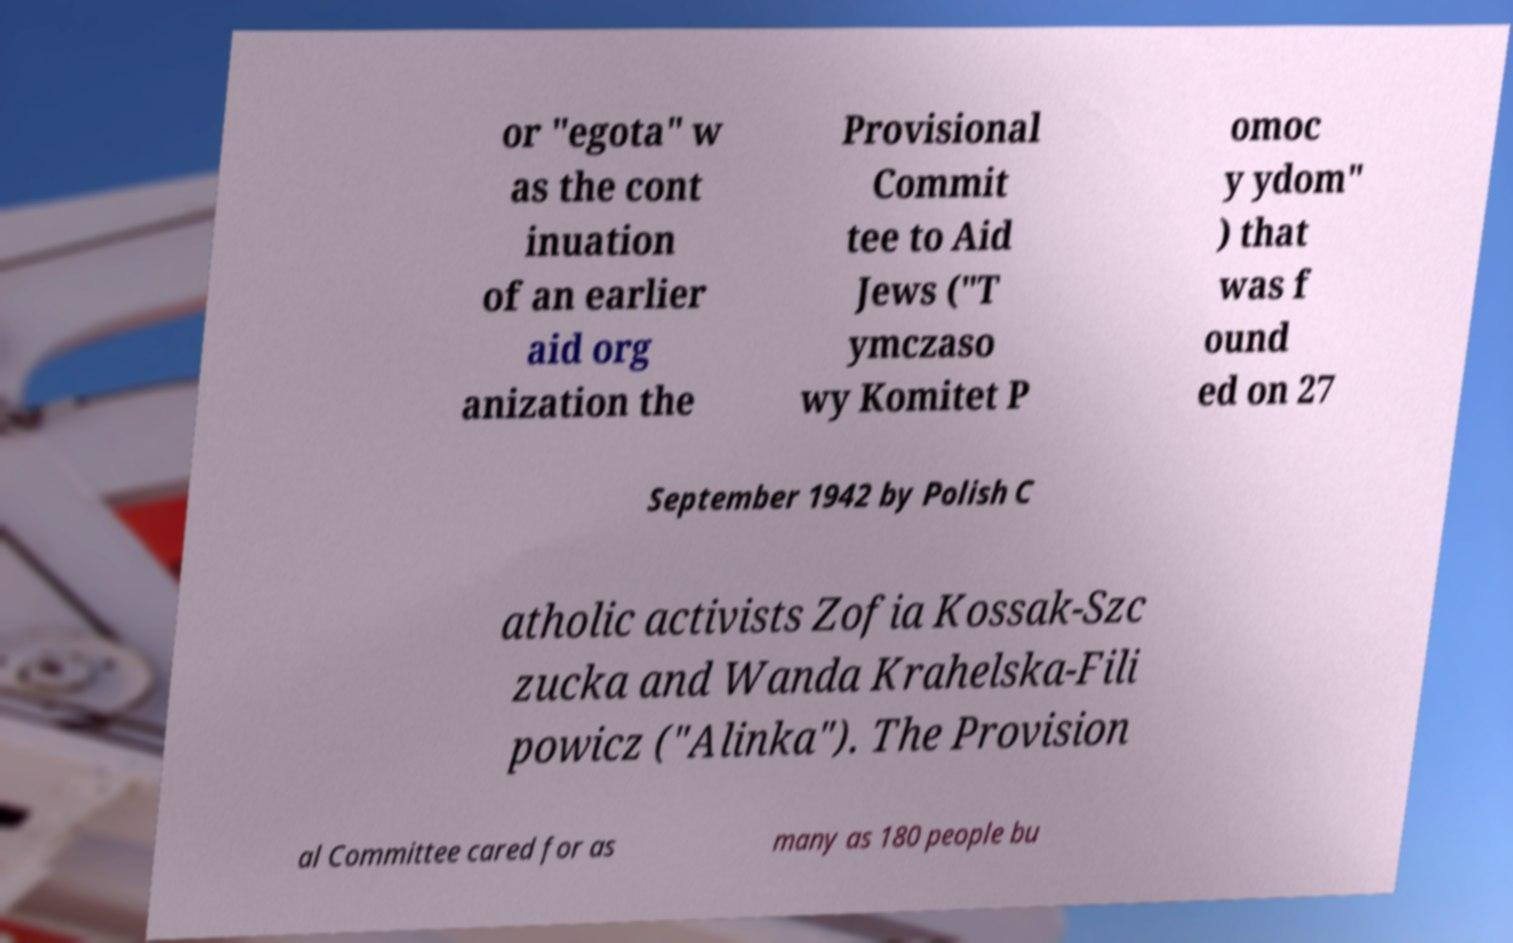What messages or text are displayed in this image? I need them in a readable, typed format. or "egota" w as the cont inuation of an earlier aid org anization the Provisional Commit tee to Aid Jews ("T ymczaso wy Komitet P omoc y ydom" ) that was f ound ed on 27 September 1942 by Polish C atholic activists Zofia Kossak-Szc zucka and Wanda Krahelska-Fili powicz ("Alinka"). The Provision al Committee cared for as many as 180 people bu 